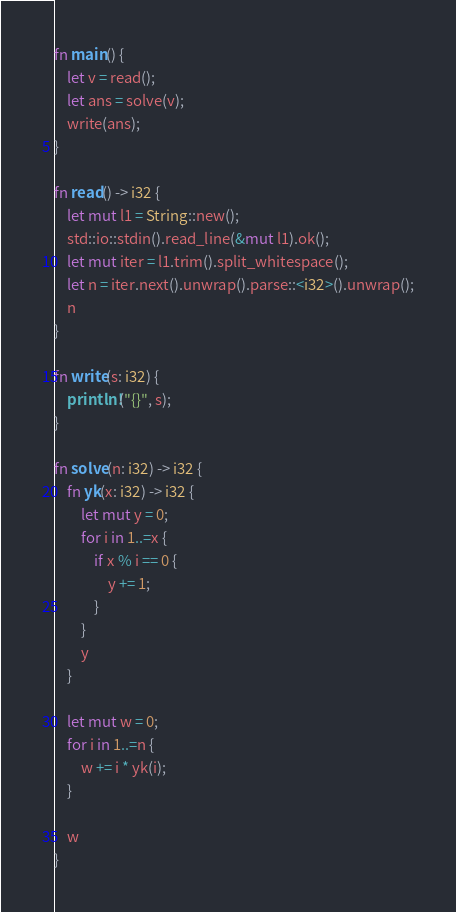<code> <loc_0><loc_0><loc_500><loc_500><_Rust_>fn main() {
    let v = read();
    let ans = solve(v);
    write(ans);
}
 
fn read() -> i32 {
    let mut l1 = String::new();
    std::io::stdin().read_line(&mut l1).ok();
    let mut iter = l1.trim().split_whitespace();
    let n = iter.next().unwrap().parse::<i32>().unwrap();
    n
}
 
fn write(s: i32) {
    println!("{}", s);
}
 
fn solve(n: i32) -> i32 {
    fn yk(x: i32) -> i32 {
        let mut y = 0;
        for i in 1..=x {
            if x % i == 0 {
                y += 1;
            }
        }
        y
    }

    let mut w = 0;
    for i in 1..=n {
        w += i * yk(i);
    }

    w
}</code> 